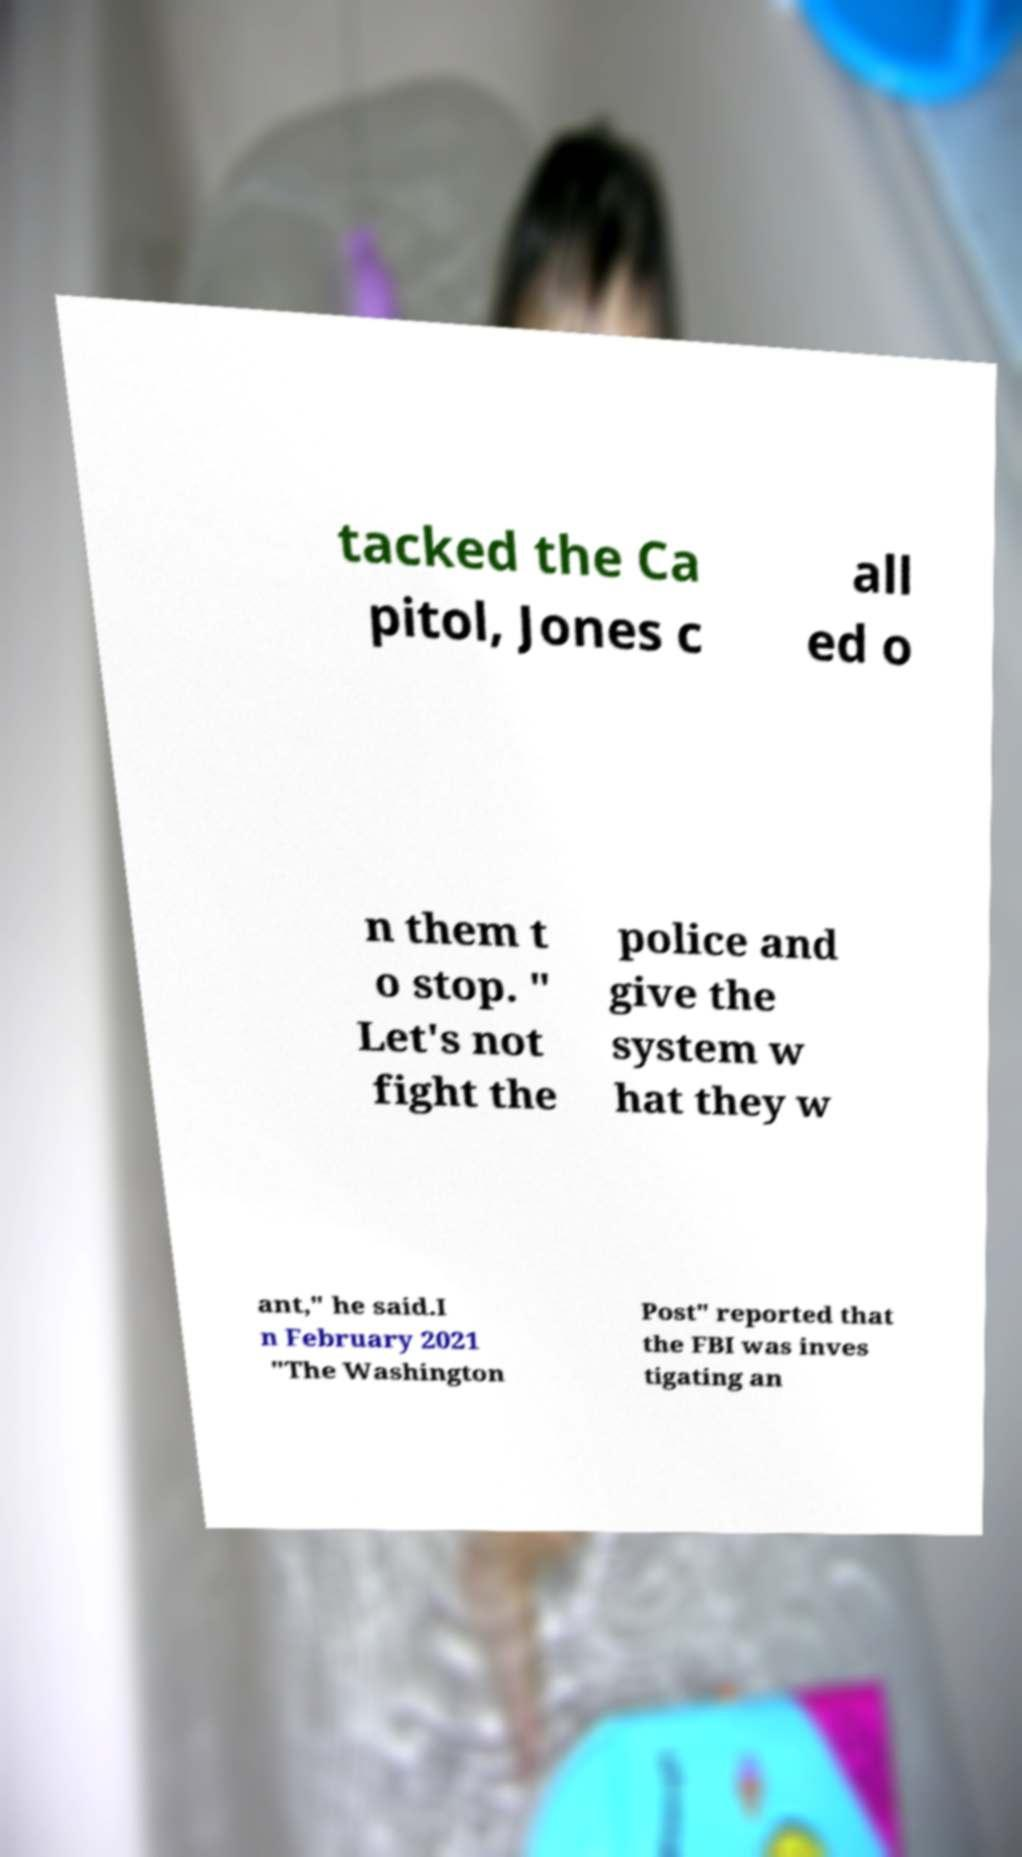There's text embedded in this image that I need extracted. Can you transcribe it verbatim? tacked the Ca pitol, Jones c all ed o n them t o stop. " Let's not fight the police and give the system w hat they w ant," he said.I n February 2021 "The Washington Post" reported that the FBI was inves tigating an 